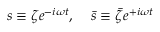<formula> <loc_0><loc_0><loc_500><loc_500>s \equiv \zeta e ^ { - i \omega t } , \, \bar { s } \equiv \bar { \zeta } e ^ { + i \omega t }</formula> 